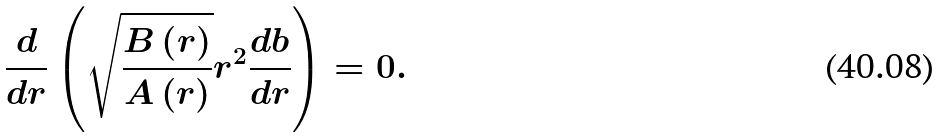Convert formula to latex. <formula><loc_0><loc_0><loc_500><loc_500>\frac { d } { d r } \left ( \sqrt { \frac { B \left ( r \right ) } { A \left ( r \right ) } } r ^ { 2 } \frac { d b } { d r } \right ) = 0 .</formula> 